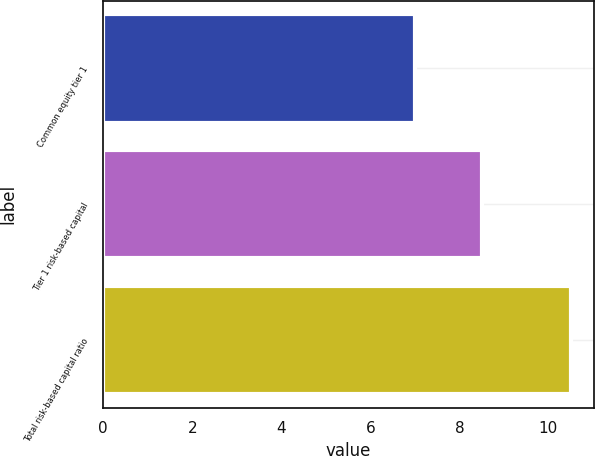Convert chart. <chart><loc_0><loc_0><loc_500><loc_500><bar_chart><fcel>Common equity tier 1<fcel>Tier 1 risk-based capital<fcel>Total risk-based capital ratio<nl><fcel>7<fcel>8.5<fcel>10.5<nl></chart> 